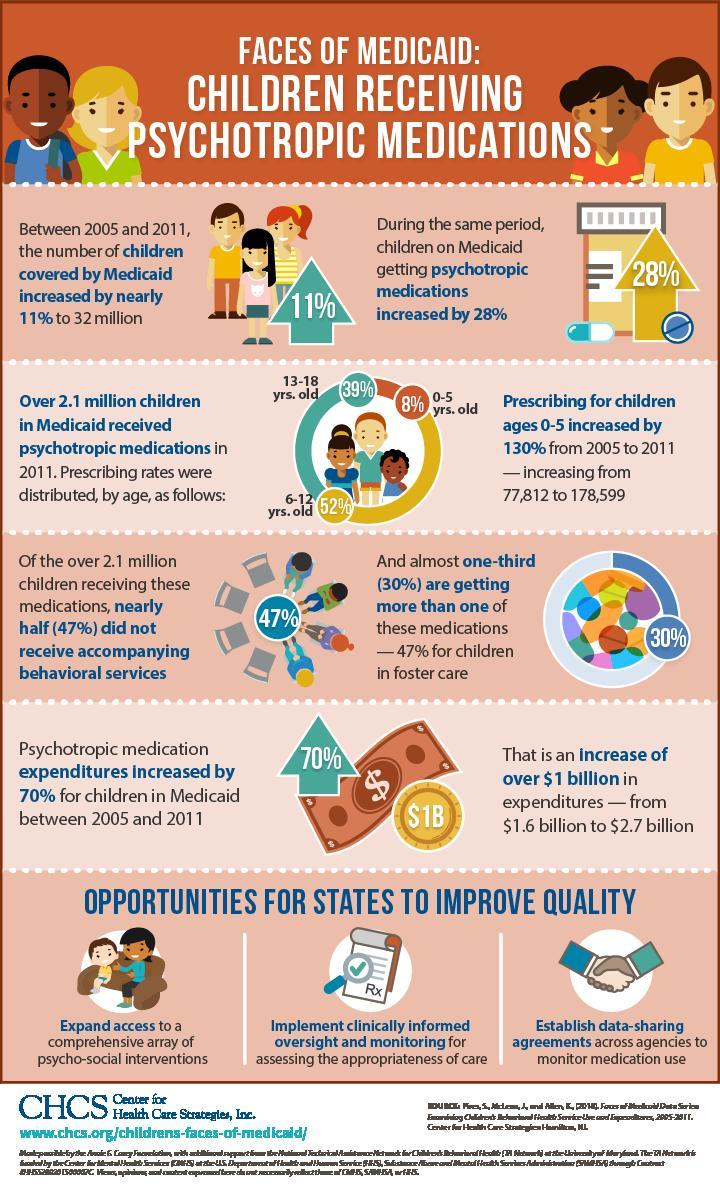Children n which age group received psychotropic drugs more?
Answer the question with a short phrase. 6-12 yrs. old By what percent did prescribing for children under the age 6 increase? 130% By what number did prescribing for children in the age 0-5 increase from 2005 to 2011? 100,787 